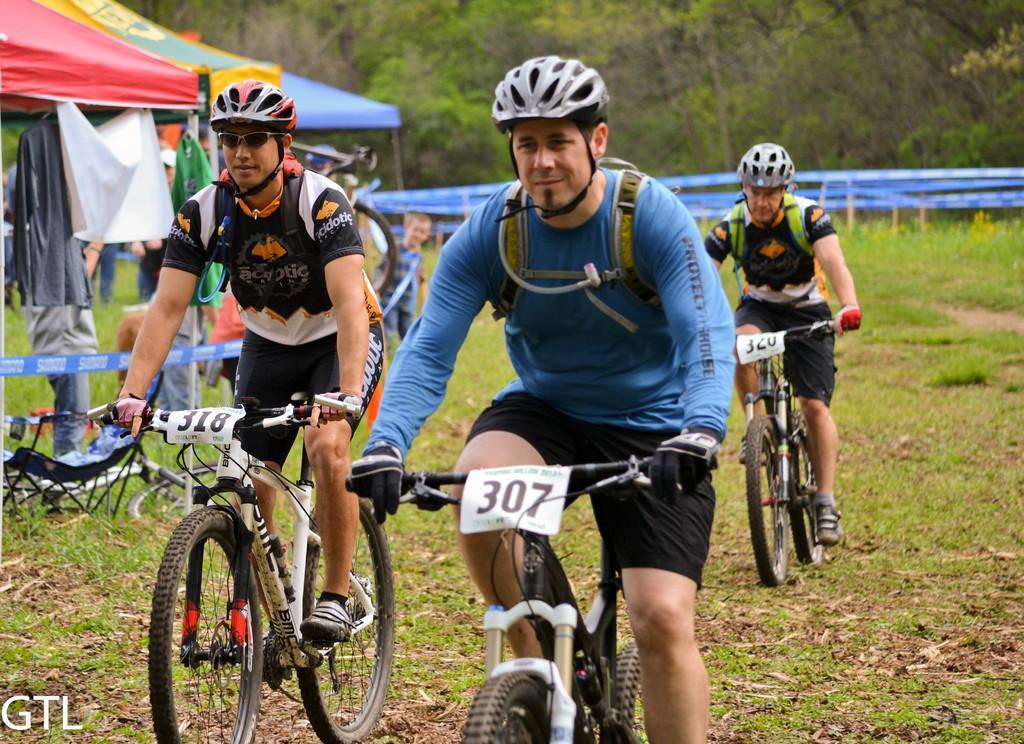How would you summarize this image in a sentence or two? In this image, we can see a group of people. Few are riding bicycles and wearing helmets. Background we can see stall, clothes, poles, tapes, chair, bicycles, plants and trees. Left side bottom corner, we can see a watermark in the image. 